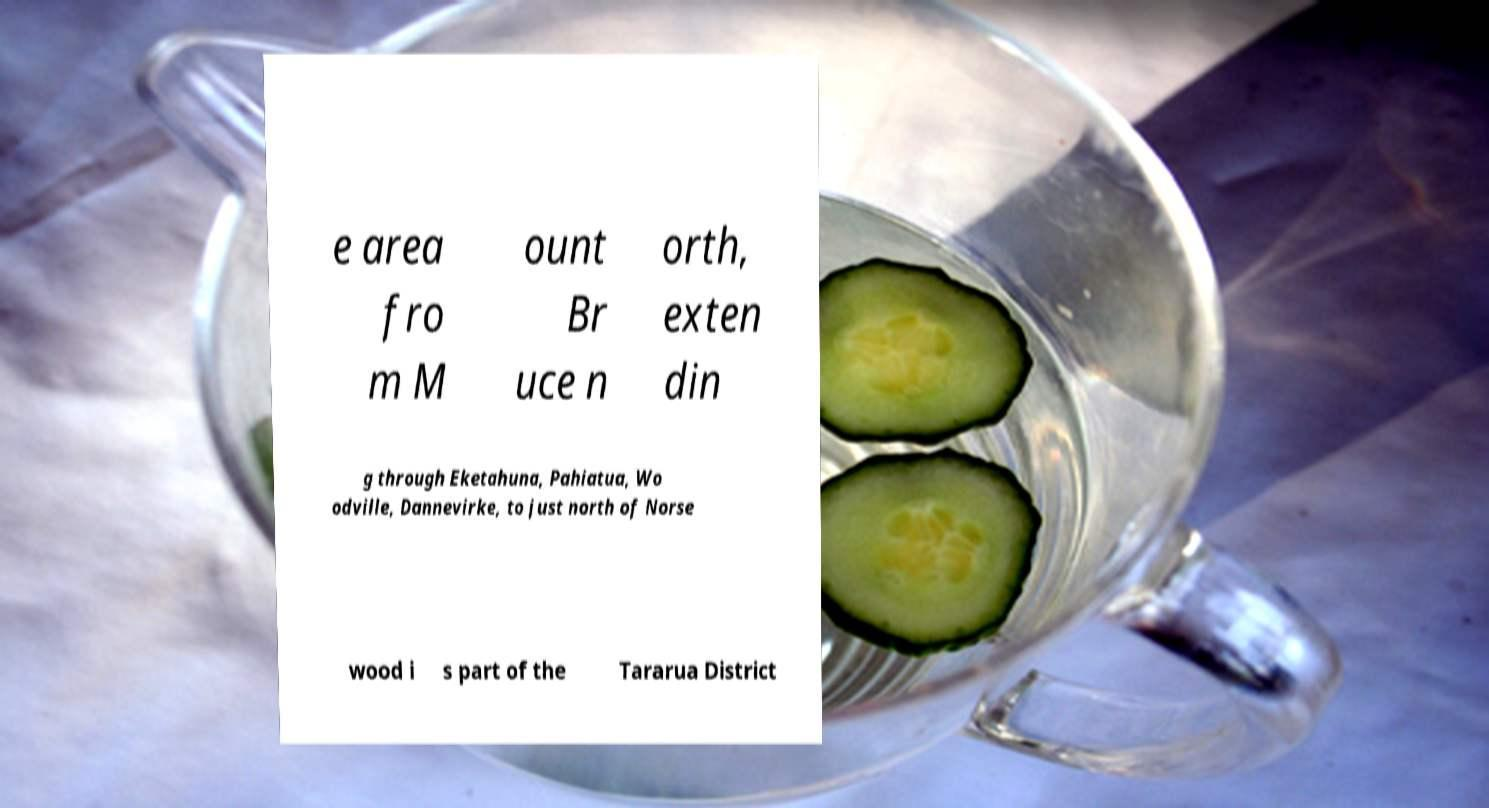Could you assist in decoding the text presented in this image and type it out clearly? e area fro m M ount Br uce n orth, exten din g through Eketahuna, Pahiatua, Wo odville, Dannevirke, to just north of Norse wood i s part of the Tararua District 